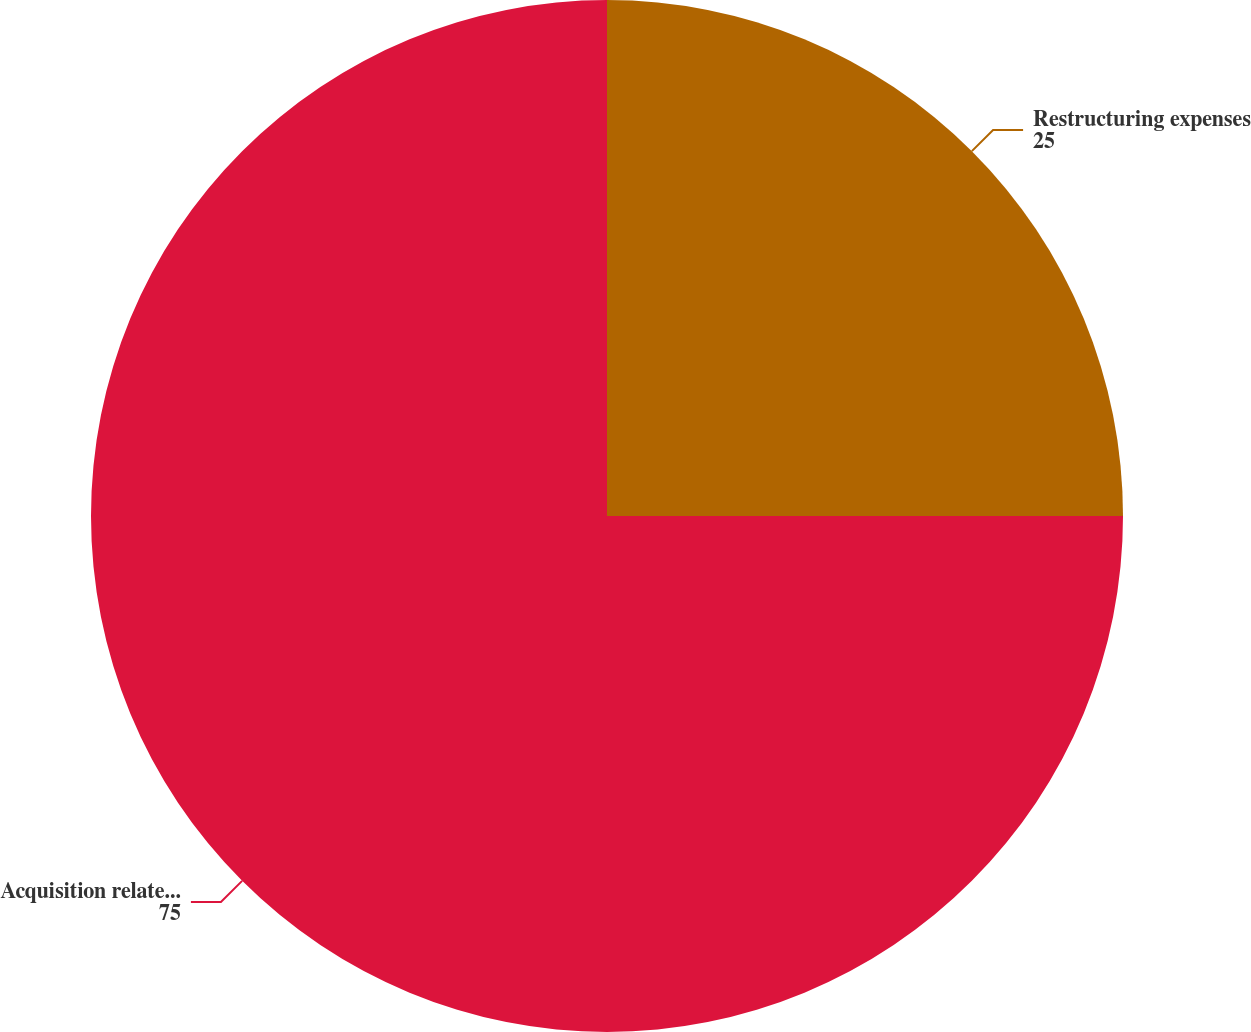Convert chart. <chart><loc_0><loc_0><loc_500><loc_500><pie_chart><fcel>Restructuring expenses<fcel>Acquisition related expenses<nl><fcel>25.0%<fcel>75.0%<nl></chart> 